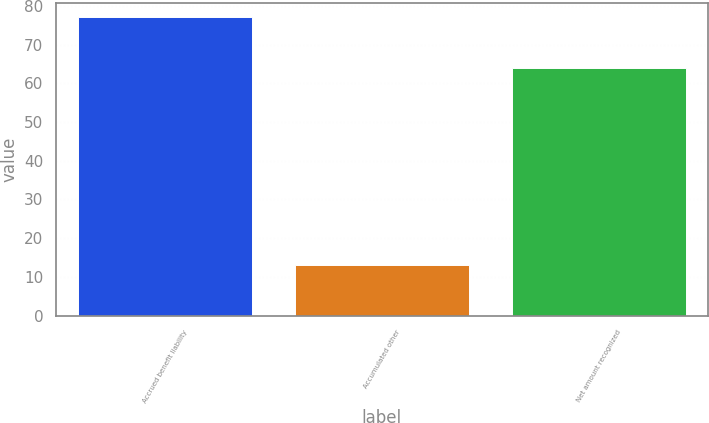Convert chart. <chart><loc_0><loc_0><loc_500><loc_500><bar_chart><fcel>Accrued benefit liability<fcel>Accumulated other<fcel>Net amount recognized<nl><fcel>77<fcel>13<fcel>64<nl></chart> 